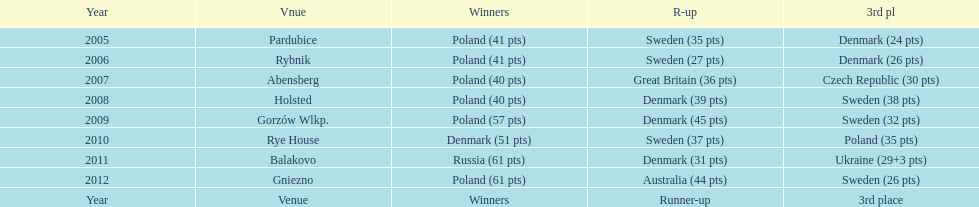Previous to 2008 how many times was sweden the runner up? 2. 